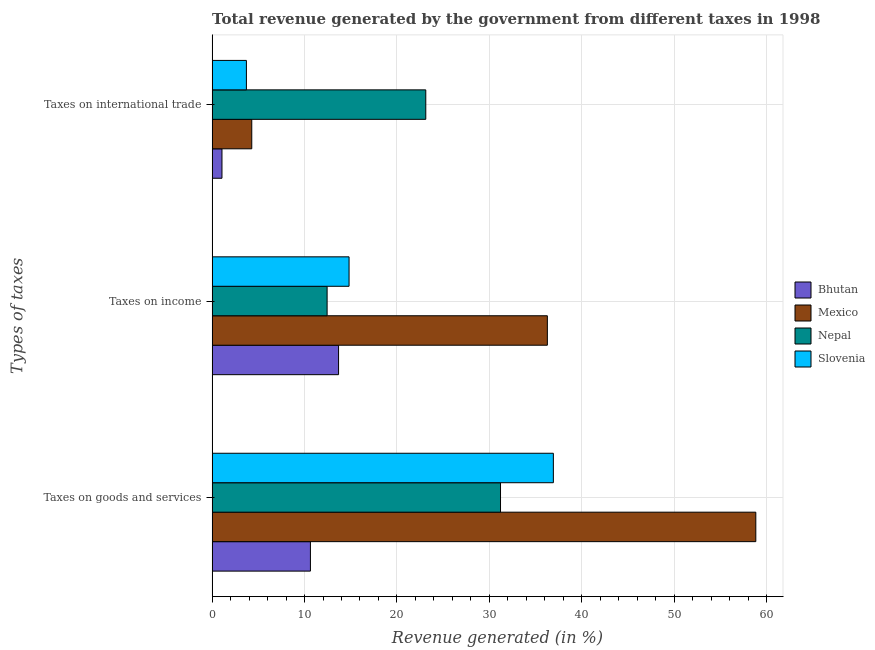How many different coloured bars are there?
Your response must be concise. 4. How many bars are there on the 3rd tick from the top?
Give a very brief answer. 4. What is the label of the 3rd group of bars from the top?
Offer a terse response. Taxes on goods and services. What is the percentage of revenue generated by tax on international trade in Bhutan?
Your answer should be compact. 1.07. Across all countries, what is the maximum percentage of revenue generated by taxes on income?
Your answer should be very brief. 36.28. Across all countries, what is the minimum percentage of revenue generated by tax on international trade?
Your response must be concise. 1.07. In which country was the percentage of revenue generated by tax on international trade maximum?
Provide a succinct answer. Nepal. In which country was the percentage of revenue generated by tax on international trade minimum?
Keep it short and to the point. Bhutan. What is the total percentage of revenue generated by tax on international trade in the graph?
Keep it short and to the point. 32.18. What is the difference between the percentage of revenue generated by tax on international trade in Bhutan and that in Slovenia?
Provide a short and direct response. -2.65. What is the difference between the percentage of revenue generated by tax on international trade in Mexico and the percentage of revenue generated by taxes on goods and services in Nepal?
Offer a very short reply. -26.92. What is the average percentage of revenue generated by tax on international trade per country?
Ensure brevity in your answer.  8.05. What is the difference between the percentage of revenue generated by taxes on goods and services and percentage of revenue generated by taxes on income in Slovenia?
Make the answer very short. 22.11. In how many countries, is the percentage of revenue generated by tax on international trade greater than 26 %?
Ensure brevity in your answer.  0. What is the ratio of the percentage of revenue generated by taxes on income in Mexico to that in Nepal?
Make the answer very short. 2.92. Is the percentage of revenue generated by taxes on goods and services in Bhutan less than that in Slovenia?
Give a very brief answer. Yes. What is the difference between the highest and the second highest percentage of revenue generated by taxes on income?
Offer a terse response. 21.46. What is the difference between the highest and the lowest percentage of revenue generated by taxes on income?
Offer a terse response. 23.83. In how many countries, is the percentage of revenue generated by tax on international trade greater than the average percentage of revenue generated by tax on international trade taken over all countries?
Offer a terse response. 1. Is the sum of the percentage of revenue generated by tax on international trade in Bhutan and Nepal greater than the maximum percentage of revenue generated by taxes on goods and services across all countries?
Give a very brief answer. No. What does the 4th bar from the top in Taxes on goods and services represents?
Give a very brief answer. Bhutan. What does the 4th bar from the bottom in Taxes on income represents?
Your response must be concise. Slovenia. Is it the case that in every country, the sum of the percentage of revenue generated by taxes on goods and services and percentage of revenue generated by taxes on income is greater than the percentage of revenue generated by tax on international trade?
Offer a very short reply. Yes. Are all the bars in the graph horizontal?
Your answer should be very brief. Yes. Does the graph contain any zero values?
Give a very brief answer. No. Does the graph contain grids?
Offer a terse response. Yes. How many legend labels are there?
Give a very brief answer. 4. What is the title of the graph?
Offer a very short reply. Total revenue generated by the government from different taxes in 1998. What is the label or title of the X-axis?
Your answer should be compact. Revenue generated (in %). What is the label or title of the Y-axis?
Offer a very short reply. Types of taxes. What is the Revenue generated (in %) of Bhutan in Taxes on goods and services?
Offer a very short reply. 10.64. What is the Revenue generated (in %) of Mexico in Taxes on goods and services?
Provide a short and direct response. 58.83. What is the Revenue generated (in %) of Nepal in Taxes on goods and services?
Your answer should be compact. 31.21. What is the Revenue generated (in %) in Slovenia in Taxes on goods and services?
Provide a succinct answer. 36.93. What is the Revenue generated (in %) in Bhutan in Taxes on income?
Provide a short and direct response. 13.68. What is the Revenue generated (in %) in Mexico in Taxes on income?
Your answer should be compact. 36.28. What is the Revenue generated (in %) in Nepal in Taxes on income?
Ensure brevity in your answer.  12.44. What is the Revenue generated (in %) in Slovenia in Taxes on income?
Provide a short and direct response. 14.82. What is the Revenue generated (in %) in Bhutan in Taxes on international trade?
Give a very brief answer. 1.07. What is the Revenue generated (in %) of Mexico in Taxes on international trade?
Make the answer very short. 4.29. What is the Revenue generated (in %) of Nepal in Taxes on international trade?
Give a very brief answer. 23.12. What is the Revenue generated (in %) in Slovenia in Taxes on international trade?
Offer a terse response. 3.71. Across all Types of taxes, what is the maximum Revenue generated (in %) of Bhutan?
Give a very brief answer. 13.68. Across all Types of taxes, what is the maximum Revenue generated (in %) of Mexico?
Offer a terse response. 58.83. Across all Types of taxes, what is the maximum Revenue generated (in %) of Nepal?
Your response must be concise. 31.21. Across all Types of taxes, what is the maximum Revenue generated (in %) of Slovenia?
Ensure brevity in your answer.  36.93. Across all Types of taxes, what is the minimum Revenue generated (in %) of Bhutan?
Your answer should be very brief. 1.07. Across all Types of taxes, what is the minimum Revenue generated (in %) of Mexico?
Your answer should be very brief. 4.29. Across all Types of taxes, what is the minimum Revenue generated (in %) of Nepal?
Offer a very short reply. 12.44. Across all Types of taxes, what is the minimum Revenue generated (in %) of Slovenia?
Ensure brevity in your answer.  3.71. What is the total Revenue generated (in %) in Bhutan in the graph?
Provide a short and direct response. 25.38. What is the total Revenue generated (in %) in Mexico in the graph?
Offer a very short reply. 99.4. What is the total Revenue generated (in %) in Nepal in the graph?
Your response must be concise. 66.77. What is the total Revenue generated (in %) in Slovenia in the graph?
Your answer should be compact. 55.46. What is the difference between the Revenue generated (in %) in Bhutan in Taxes on goods and services and that in Taxes on income?
Your answer should be compact. -3.04. What is the difference between the Revenue generated (in %) in Mexico in Taxes on goods and services and that in Taxes on income?
Offer a terse response. 22.56. What is the difference between the Revenue generated (in %) in Nepal in Taxes on goods and services and that in Taxes on income?
Offer a very short reply. 18.76. What is the difference between the Revenue generated (in %) in Slovenia in Taxes on goods and services and that in Taxes on income?
Ensure brevity in your answer.  22.11. What is the difference between the Revenue generated (in %) in Bhutan in Taxes on goods and services and that in Taxes on international trade?
Ensure brevity in your answer.  9.57. What is the difference between the Revenue generated (in %) in Mexico in Taxes on goods and services and that in Taxes on international trade?
Provide a succinct answer. 54.54. What is the difference between the Revenue generated (in %) of Nepal in Taxes on goods and services and that in Taxes on international trade?
Your response must be concise. 8.09. What is the difference between the Revenue generated (in %) in Slovenia in Taxes on goods and services and that in Taxes on international trade?
Provide a succinct answer. 33.22. What is the difference between the Revenue generated (in %) of Bhutan in Taxes on income and that in Taxes on international trade?
Make the answer very short. 12.62. What is the difference between the Revenue generated (in %) of Mexico in Taxes on income and that in Taxes on international trade?
Give a very brief answer. 31.99. What is the difference between the Revenue generated (in %) of Nepal in Taxes on income and that in Taxes on international trade?
Your answer should be very brief. -10.68. What is the difference between the Revenue generated (in %) in Slovenia in Taxes on income and that in Taxes on international trade?
Your answer should be very brief. 11.11. What is the difference between the Revenue generated (in %) in Bhutan in Taxes on goods and services and the Revenue generated (in %) in Mexico in Taxes on income?
Provide a succinct answer. -25.64. What is the difference between the Revenue generated (in %) in Bhutan in Taxes on goods and services and the Revenue generated (in %) in Nepal in Taxes on income?
Give a very brief answer. -1.81. What is the difference between the Revenue generated (in %) in Bhutan in Taxes on goods and services and the Revenue generated (in %) in Slovenia in Taxes on income?
Provide a short and direct response. -4.18. What is the difference between the Revenue generated (in %) of Mexico in Taxes on goods and services and the Revenue generated (in %) of Nepal in Taxes on income?
Your response must be concise. 46.39. What is the difference between the Revenue generated (in %) of Mexico in Taxes on goods and services and the Revenue generated (in %) of Slovenia in Taxes on income?
Provide a succinct answer. 44.01. What is the difference between the Revenue generated (in %) in Nepal in Taxes on goods and services and the Revenue generated (in %) in Slovenia in Taxes on income?
Provide a short and direct response. 16.39. What is the difference between the Revenue generated (in %) of Bhutan in Taxes on goods and services and the Revenue generated (in %) of Mexico in Taxes on international trade?
Ensure brevity in your answer.  6.35. What is the difference between the Revenue generated (in %) of Bhutan in Taxes on goods and services and the Revenue generated (in %) of Nepal in Taxes on international trade?
Provide a short and direct response. -12.48. What is the difference between the Revenue generated (in %) in Bhutan in Taxes on goods and services and the Revenue generated (in %) in Slovenia in Taxes on international trade?
Ensure brevity in your answer.  6.93. What is the difference between the Revenue generated (in %) in Mexico in Taxes on goods and services and the Revenue generated (in %) in Nepal in Taxes on international trade?
Your answer should be compact. 35.71. What is the difference between the Revenue generated (in %) in Mexico in Taxes on goods and services and the Revenue generated (in %) in Slovenia in Taxes on international trade?
Your answer should be compact. 55.12. What is the difference between the Revenue generated (in %) in Nepal in Taxes on goods and services and the Revenue generated (in %) in Slovenia in Taxes on international trade?
Offer a very short reply. 27.5. What is the difference between the Revenue generated (in %) of Bhutan in Taxes on income and the Revenue generated (in %) of Mexico in Taxes on international trade?
Give a very brief answer. 9.39. What is the difference between the Revenue generated (in %) of Bhutan in Taxes on income and the Revenue generated (in %) of Nepal in Taxes on international trade?
Make the answer very short. -9.44. What is the difference between the Revenue generated (in %) in Bhutan in Taxes on income and the Revenue generated (in %) in Slovenia in Taxes on international trade?
Keep it short and to the point. 9.97. What is the difference between the Revenue generated (in %) of Mexico in Taxes on income and the Revenue generated (in %) of Nepal in Taxes on international trade?
Your answer should be compact. 13.16. What is the difference between the Revenue generated (in %) of Mexico in Taxes on income and the Revenue generated (in %) of Slovenia in Taxes on international trade?
Offer a very short reply. 32.57. What is the difference between the Revenue generated (in %) in Nepal in Taxes on income and the Revenue generated (in %) in Slovenia in Taxes on international trade?
Your answer should be very brief. 8.73. What is the average Revenue generated (in %) of Bhutan per Types of taxes?
Your answer should be compact. 8.46. What is the average Revenue generated (in %) of Mexico per Types of taxes?
Provide a succinct answer. 33.13. What is the average Revenue generated (in %) in Nepal per Types of taxes?
Your answer should be very brief. 22.26. What is the average Revenue generated (in %) in Slovenia per Types of taxes?
Your response must be concise. 18.49. What is the difference between the Revenue generated (in %) of Bhutan and Revenue generated (in %) of Mexico in Taxes on goods and services?
Offer a very short reply. -48.2. What is the difference between the Revenue generated (in %) of Bhutan and Revenue generated (in %) of Nepal in Taxes on goods and services?
Make the answer very short. -20.57. What is the difference between the Revenue generated (in %) in Bhutan and Revenue generated (in %) in Slovenia in Taxes on goods and services?
Your answer should be compact. -26.29. What is the difference between the Revenue generated (in %) in Mexico and Revenue generated (in %) in Nepal in Taxes on goods and services?
Offer a terse response. 27.63. What is the difference between the Revenue generated (in %) in Mexico and Revenue generated (in %) in Slovenia in Taxes on goods and services?
Make the answer very short. 21.91. What is the difference between the Revenue generated (in %) in Nepal and Revenue generated (in %) in Slovenia in Taxes on goods and services?
Make the answer very short. -5.72. What is the difference between the Revenue generated (in %) of Bhutan and Revenue generated (in %) of Mexico in Taxes on income?
Give a very brief answer. -22.59. What is the difference between the Revenue generated (in %) of Bhutan and Revenue generated (in %) of Nepal in Taxes on income?
Give a very brief answer. 1.24. What is the difference between the Revenue generated (in %) of Bhutan and Revenue generated (in %) of Slovenia in Taxes on income?
Provide a short and direct response. -1.14. What is the difference between the Revenue generated (in %) of Mexico and Revenue generated (in %) of Nepal in Taxes on income?
Give a very brief answer. 23.83. What is the difference between the Revenue generated (in %) of Mexico and Revenue generated (in %) of Slovenia in Taxes on income?
Ensure brevity in your answer.  21.46. What is the difference between the Revenue generated (in %) in Nepal and Revenue generated (in %) in Slovenia in Taxes on income?
Keep it short and to the point. -2.38. What is the difference between the Revenue generated (in %) of Bhutan and Revenue generated (in %) of Mexico in Taxes on international trade?
Offer a very short reply. -3.22. What is the difference between the Revenue generated (in %) of Bhutan and Revenue generated (in %) of Nepal in Taxes on international trade?
Give a very brief answer. -22.05. What is the difference between the Revenue generated (in %) of Bhutan and Revenue generated (in %) of Slovenia in Taxes on international trade?
Offer a very short reply. -2.65. What is the difference between the Revenue generated (in %) of Mexico and Revenue generated (in %) of Nepal in Taxes on international trade?
Provide a short and direct response. -18.83. What is the difference between the Revenue generated (in %) in Mexico and Revenue generated (in %) in Slovenia in Taxes on international trade?
Your answer should be compact. 0.58. What is the difference between the Revenue generated (in %) in Nepal and Revenue generated (in %) in Slovenia in Taxes on international trade?
Give a very brief answer. 19.41. What is the ratio of the Revenue generated (in %) of Bhutan in Taxes on goods and services to that in Taxes on income?
Keep it short and to the point. 0.78. What is the ratio of the Revenue generated (in %) in Mexico in Taxes on goods and services to that in Taxes on income?
Offer a very short reply. 1.62. What is the ratio of the Revenue generated (in %) in Nepal in Taxes on goods and services to that in Taxes on income?
Your answer should be very brief. 2.51. What is the ratio of the Revenue generated (in %) of Slovenia in Taxes on goods and services to that in Taxes on income?
Provide a succinct answer. 2.49. What is the ratio of the Revenue generated (in %) of Bhutan in Taxes on goods and services to that in Taxes on international trade?
Keep it short and to the point. 9.99. What is the ratio of the Revenue generated (in %) in Mexico in Taxes on goods and services to that in Taxes on international trade?
Your response must be concise. 13.72. What is the ratio of the Revenue generated (in %) in Nepal in Taxes on goods and services to that in Taxes on international trade?
Ensure brevity in your answer.  1.35. What is the ratio of the Revenue generated (in %) in Slovenia in Taxes on goods and services to that in Taxes on international trade?
Your answer should be compact. 9.95. What is the ratio of the Revenue generated (in %) of Bhutan in Taxes on income to that in Taxes on international trade?
Ensure brevity in your answer.  12.84. What is the ratio of the Revenue generated (in %) of Mexico in Taxes on income to that in Taxes on international trade?
Your answer should be very brief. 8.46. What is the ratio of the Revenue generated (in %) in Nepal in Taxes on income to that in Taxes on international trade?
Provide a short and direct response. 0.54. What is the ratio of the Revenue generated (in %) in Slovenia in Taxes on income to that in Taxes on international trade?
Keep it short and to the point. 3.99. What is the difference between the highest and the second highest Revenue generated (in %) of Bhutan?
Offer a terse response. 3.04. What is the difference between the highest and the second highest Revenue generated (in %) in Mexico?
Keep it short and to the point. 22.56. What is the difference between the highest and the second highest Revenue generated (in %) of Nepal?
Make the answer very short. 8.09. What is the difference between the highest and the second highest Revenue generated (in %) of Slovenia?
Your answer should be very brief. 22.11. What is the difference between the highest and the lowest Revenue generated (in %) in Bhutan?
Your answer should be compact. 12.62. What is the difference between the highest and the lowest Revenue generated (in %) of Mexico?
Provide a short and direct response. 54.54. What is the difference between the highest and the lowest Revenue generated (in %) of Nepal?
Provide a succinct answer. 18.76. What is the difference between the highest and the lowest Revenue generated (in %) of Slovenia?
Provide a succinct answer. 33.22. 